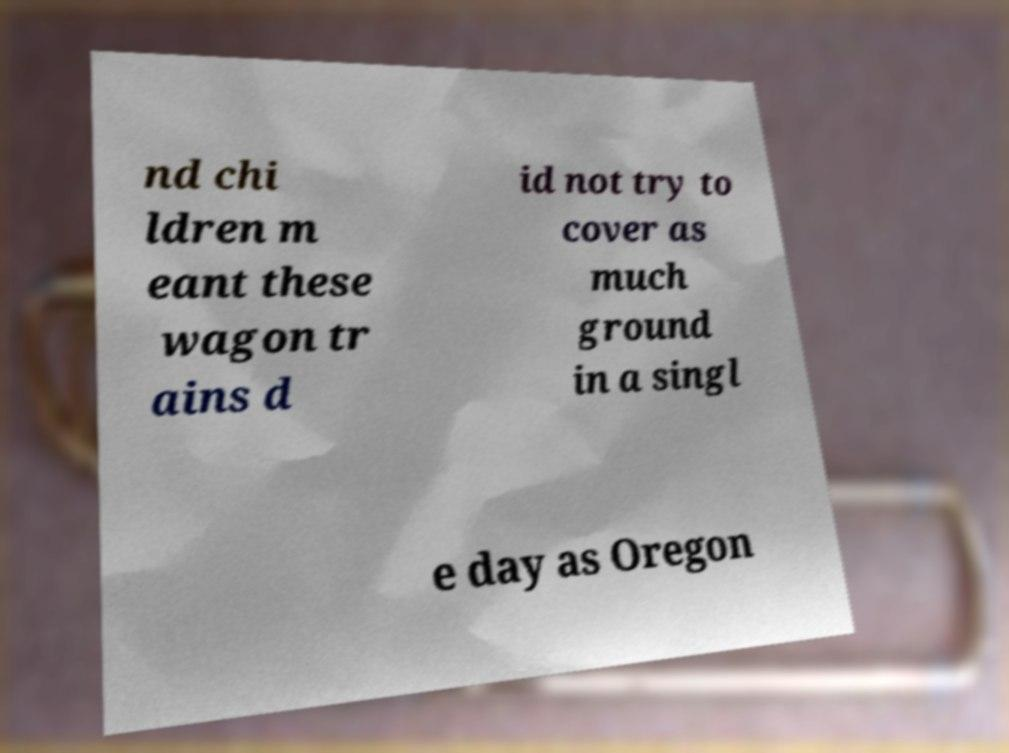Please identify and transcribe the text found in this image. nd chi ldren m eant these wagon tr ains d id not try to cover as much ground in a singl e day as Oregon 